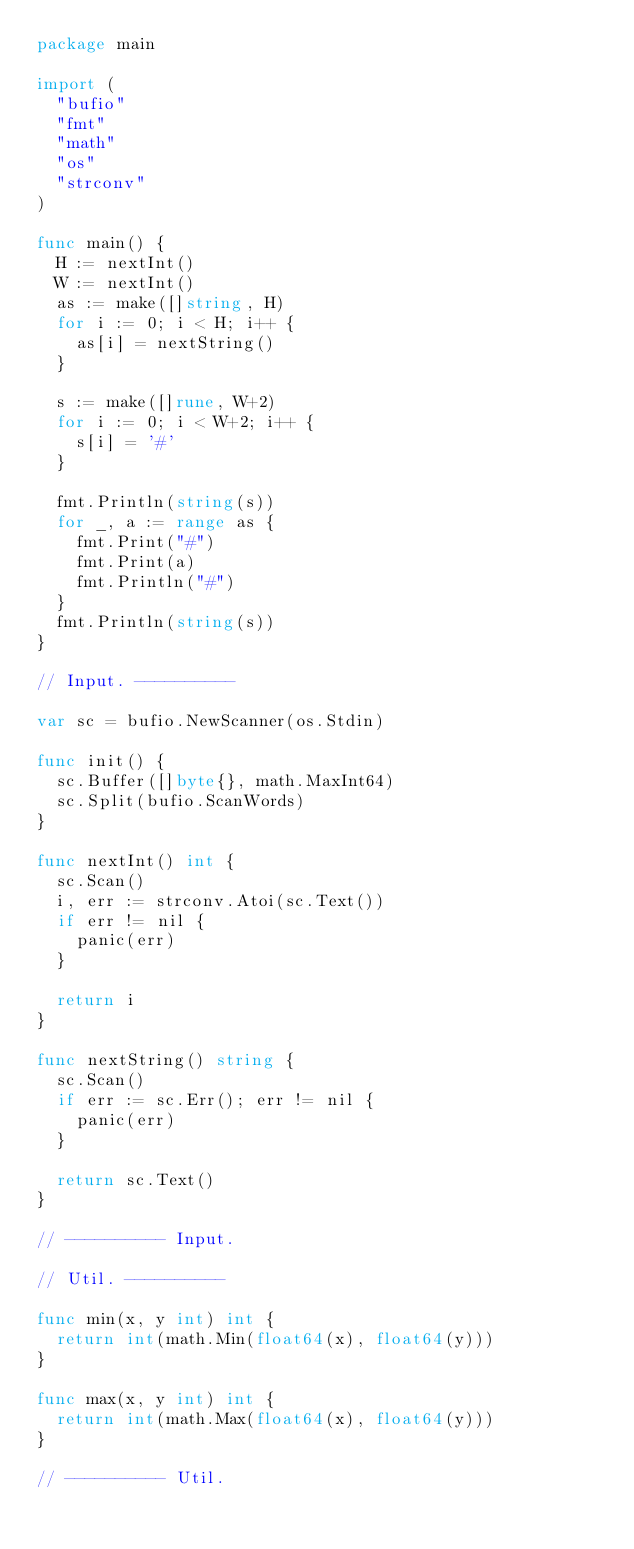<code> <loc_0><loc_0><loc_500><loc_500><_Go_>package main

import (
	"bufio"
	"fmt"
	"math"
	"os"
	"strconv"
)

func main() {
	H := nextInt()
	W := nextInt()
	as := make([]string, H)
	for i := 0; i < H; i++ {
		as[i] = nextString()
	}

	s := make([]rune, W+2)
	for i := 0; i < W+2; i++ {
		s[i] = '#'
	}

	fmt.Println(string(s))
	for _, a := range as {
		fmt.Print("#")
		fmt.Print(a)
		fmt.Println("#")
	}
	fmt.Println(string(s))
}

// Input. ----------

var sc = bufio.NewScanner(os.Stdin)

func init() {
	sc.Buffer([]byte{}, math.MaxInt64)
	sc.Split(bufio.ScanWords)
}

func nextInt() int {
	sc.Scan()
	i, err := strconv.Atoi(sc.Text())
	if err != nil {
		panic(err)
	}

	return i
}

func nextString() string {
	sc.Scan()
	if err := sc.Err(); err != nil {
		panic(err)
	}

	return sc.Text()
}

// ---------- Input.

// Util. ----------

func min(x, y int) int {
	return int(math.Min(float64(x), float64(y)))
}

func max(x, y int) int {
	return int(math.Max(float64(x), float64(y)))
}

// ---------- Util.
</code> 